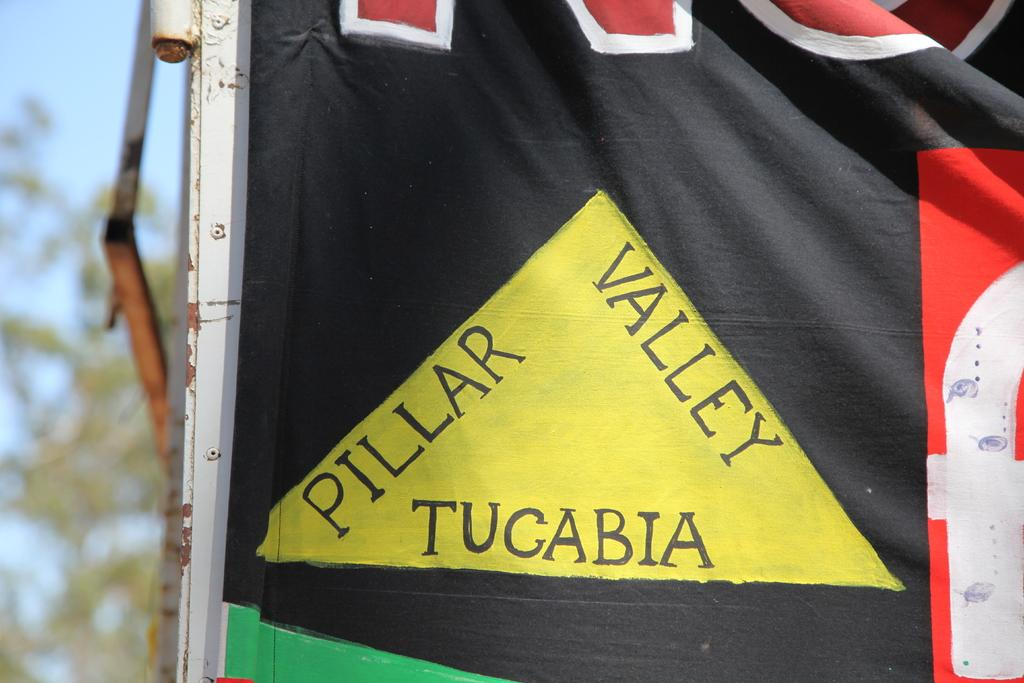What is present in the image that has text on it? There is a cloth in the image that contains some text. Can you describe the background of the image? The background of the image is blurred. What type of sock can be seen in the image? There is no sock present in the image. Is there any snow visible in the image? There is no snow present in the image. What role does the straw play in the image? There is no straw present in the image. 